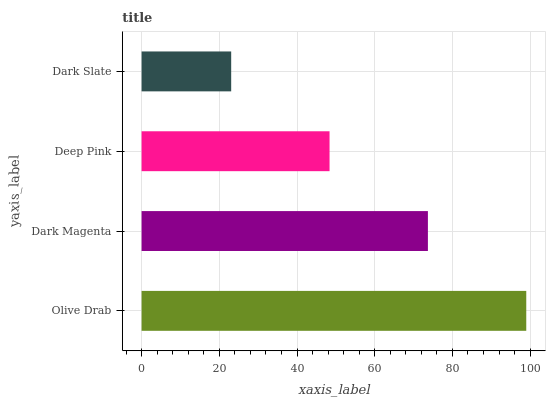Is Dark Slate the minimum?
Answer yes or no. Yes. Is Olive Drab the maximum?
Answer yes or no. Yes. Is Dark Magenta the minimum?
Answer yes or no. No. Is Dark Magenta the maximum?
Answer yes or no. No. Is Olive Drab greater than Dark Magenta?
Answer yes or no. Yes. Is Dark Magenta less than Olive Drab?
Answer yes or no. Yes. Is Dark Magenta greater than Olive Drab?
Answer yes or no. No. Is Olive Drab less than Dark Magenta?
Answer yes or no. No. Is Dark Magenta the high median?
Answer yes or no. Yes. Is Deep Pink the low median?
Answer yes or no. Yes. Is Dark Slate the high median?
Answer yes or no. No. Is Olive Drab the low median?
Answer yes or no. No. 